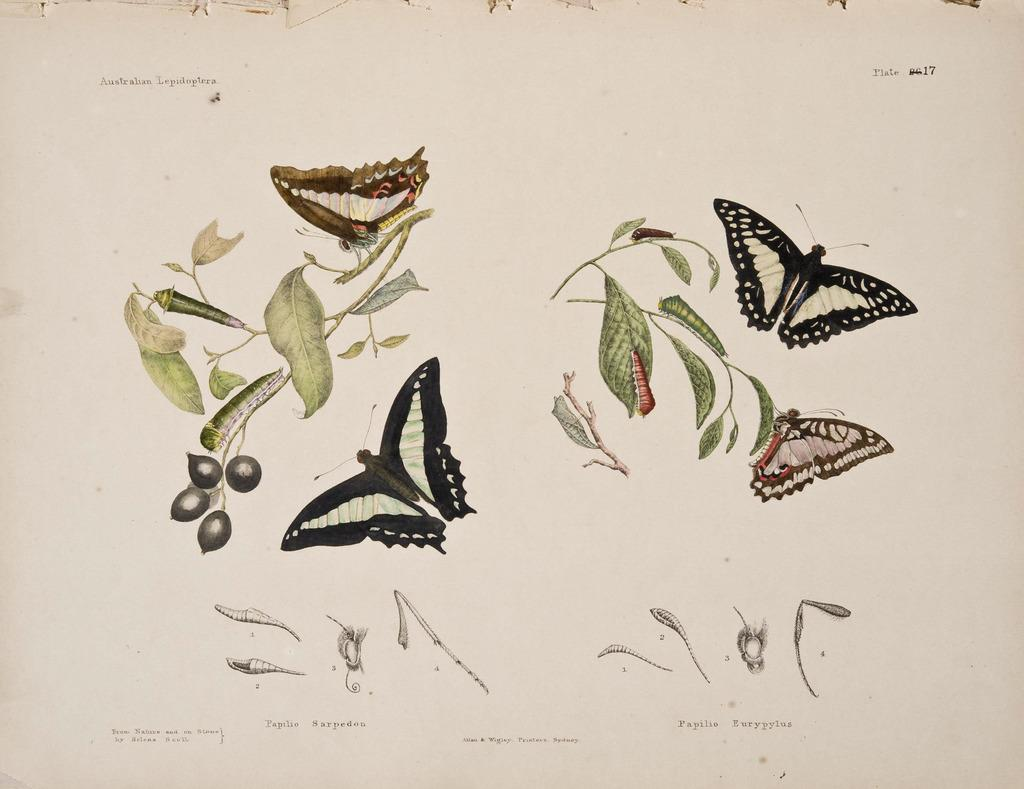What is the main subject of the picture? The main subject of the picture is a paper. What is depicted on the paper? The paper contains images of insects. Is there any text on the paper? Yes, there is text at the bottom of the paper. How many cats are visible in the image? There are no cats present in the image; it features a paper with images of insects and text. What type of transport is shown in the image? There is no transport depicted in the image; it only contains a paper with insect images and text. 